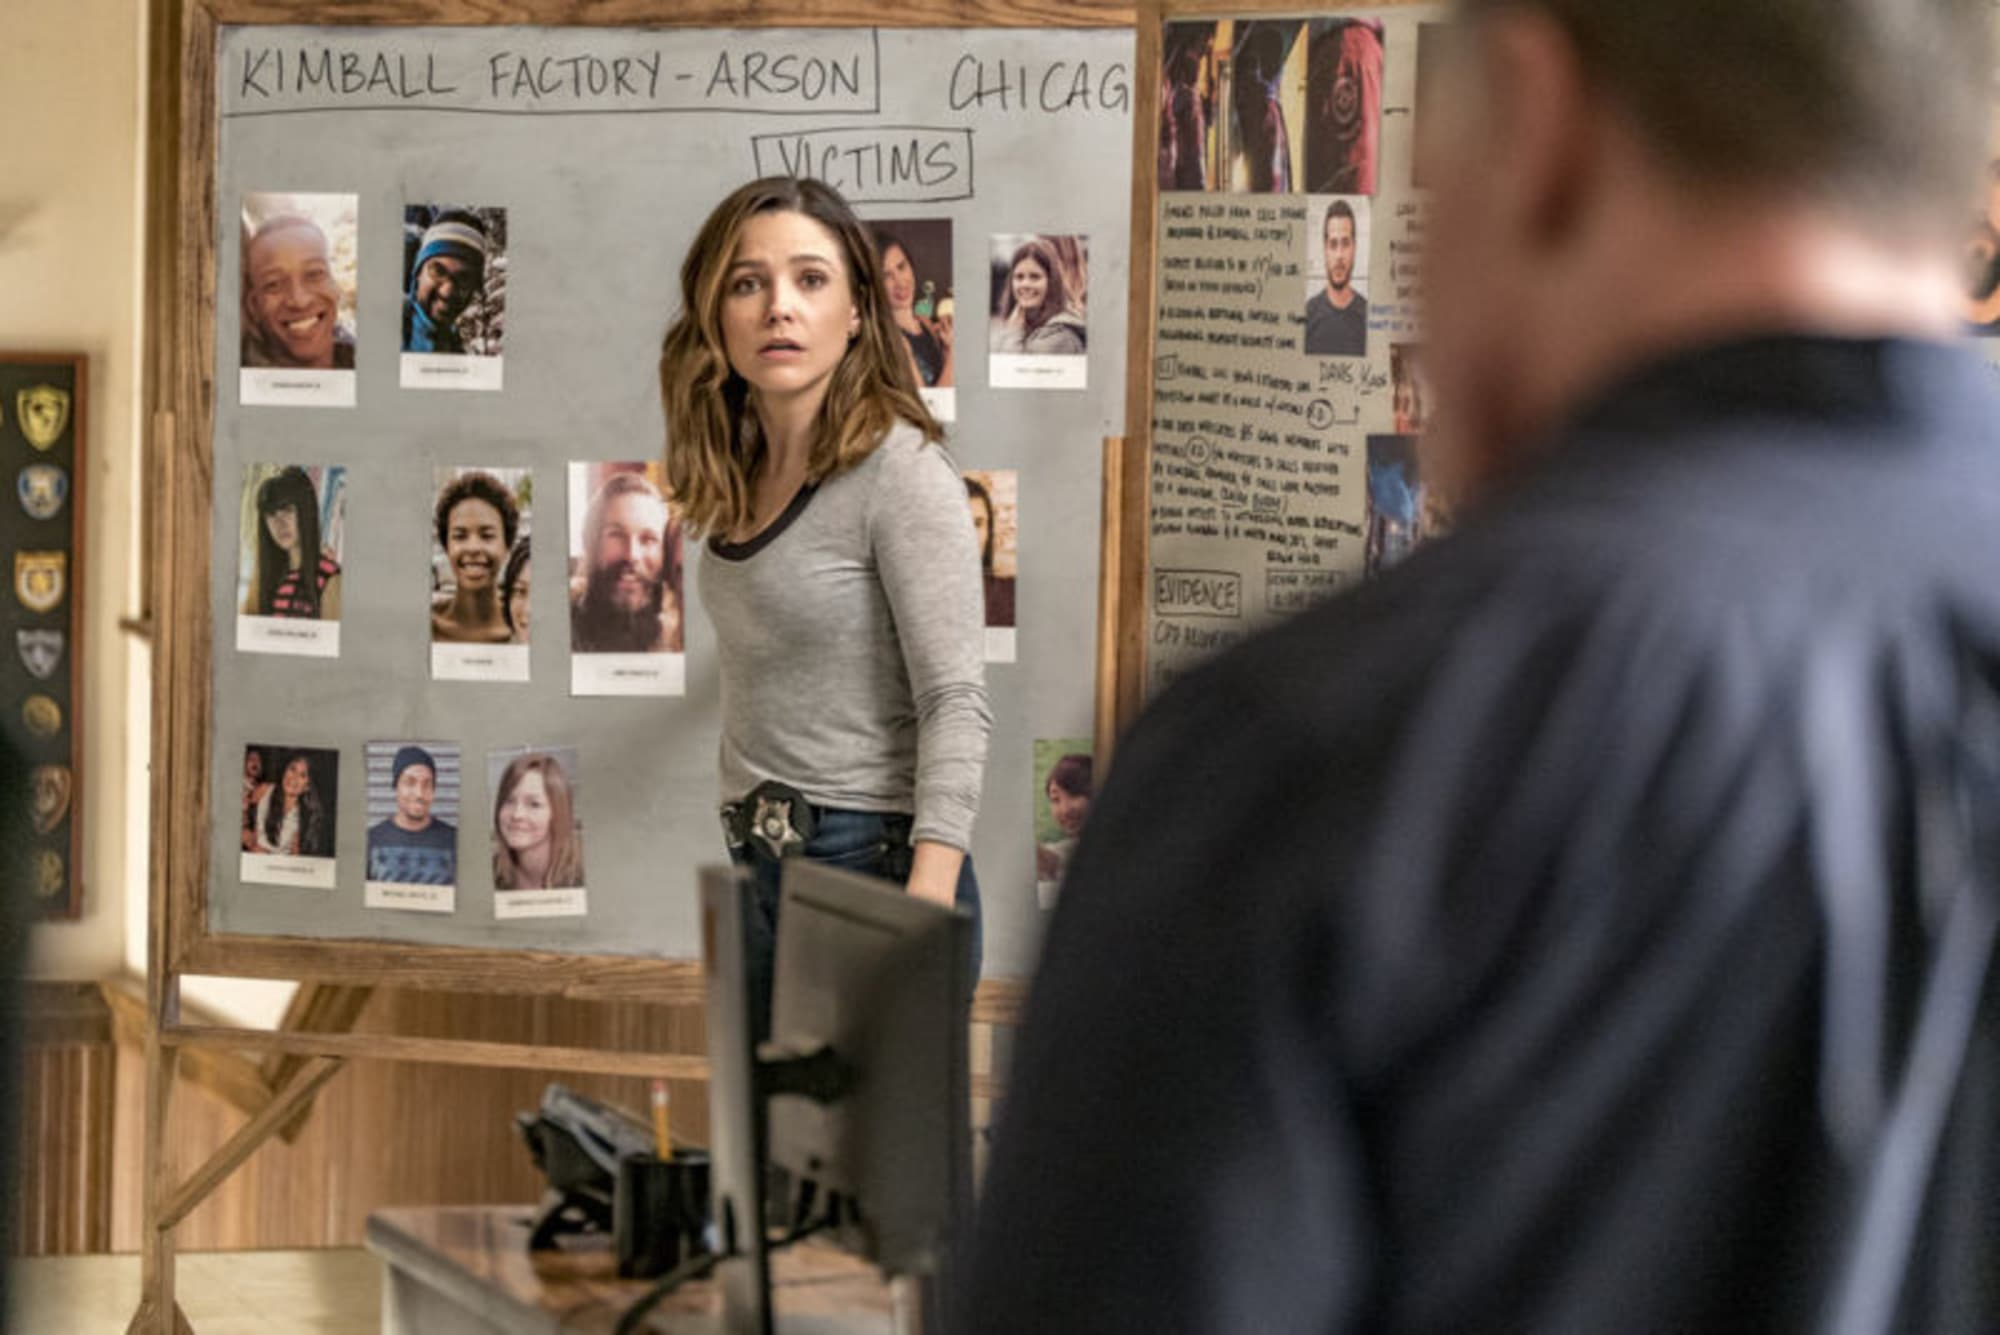What can you tell me about the mood in this scene? The mood in the scene is quite serious and somber. The focused expressions and the subject matter of the bulletin board indicate a grave investigation into a tragic event. The setting suggests a police or detective environment, heightening the sense of urgency and the critical nature of the work at hand. 